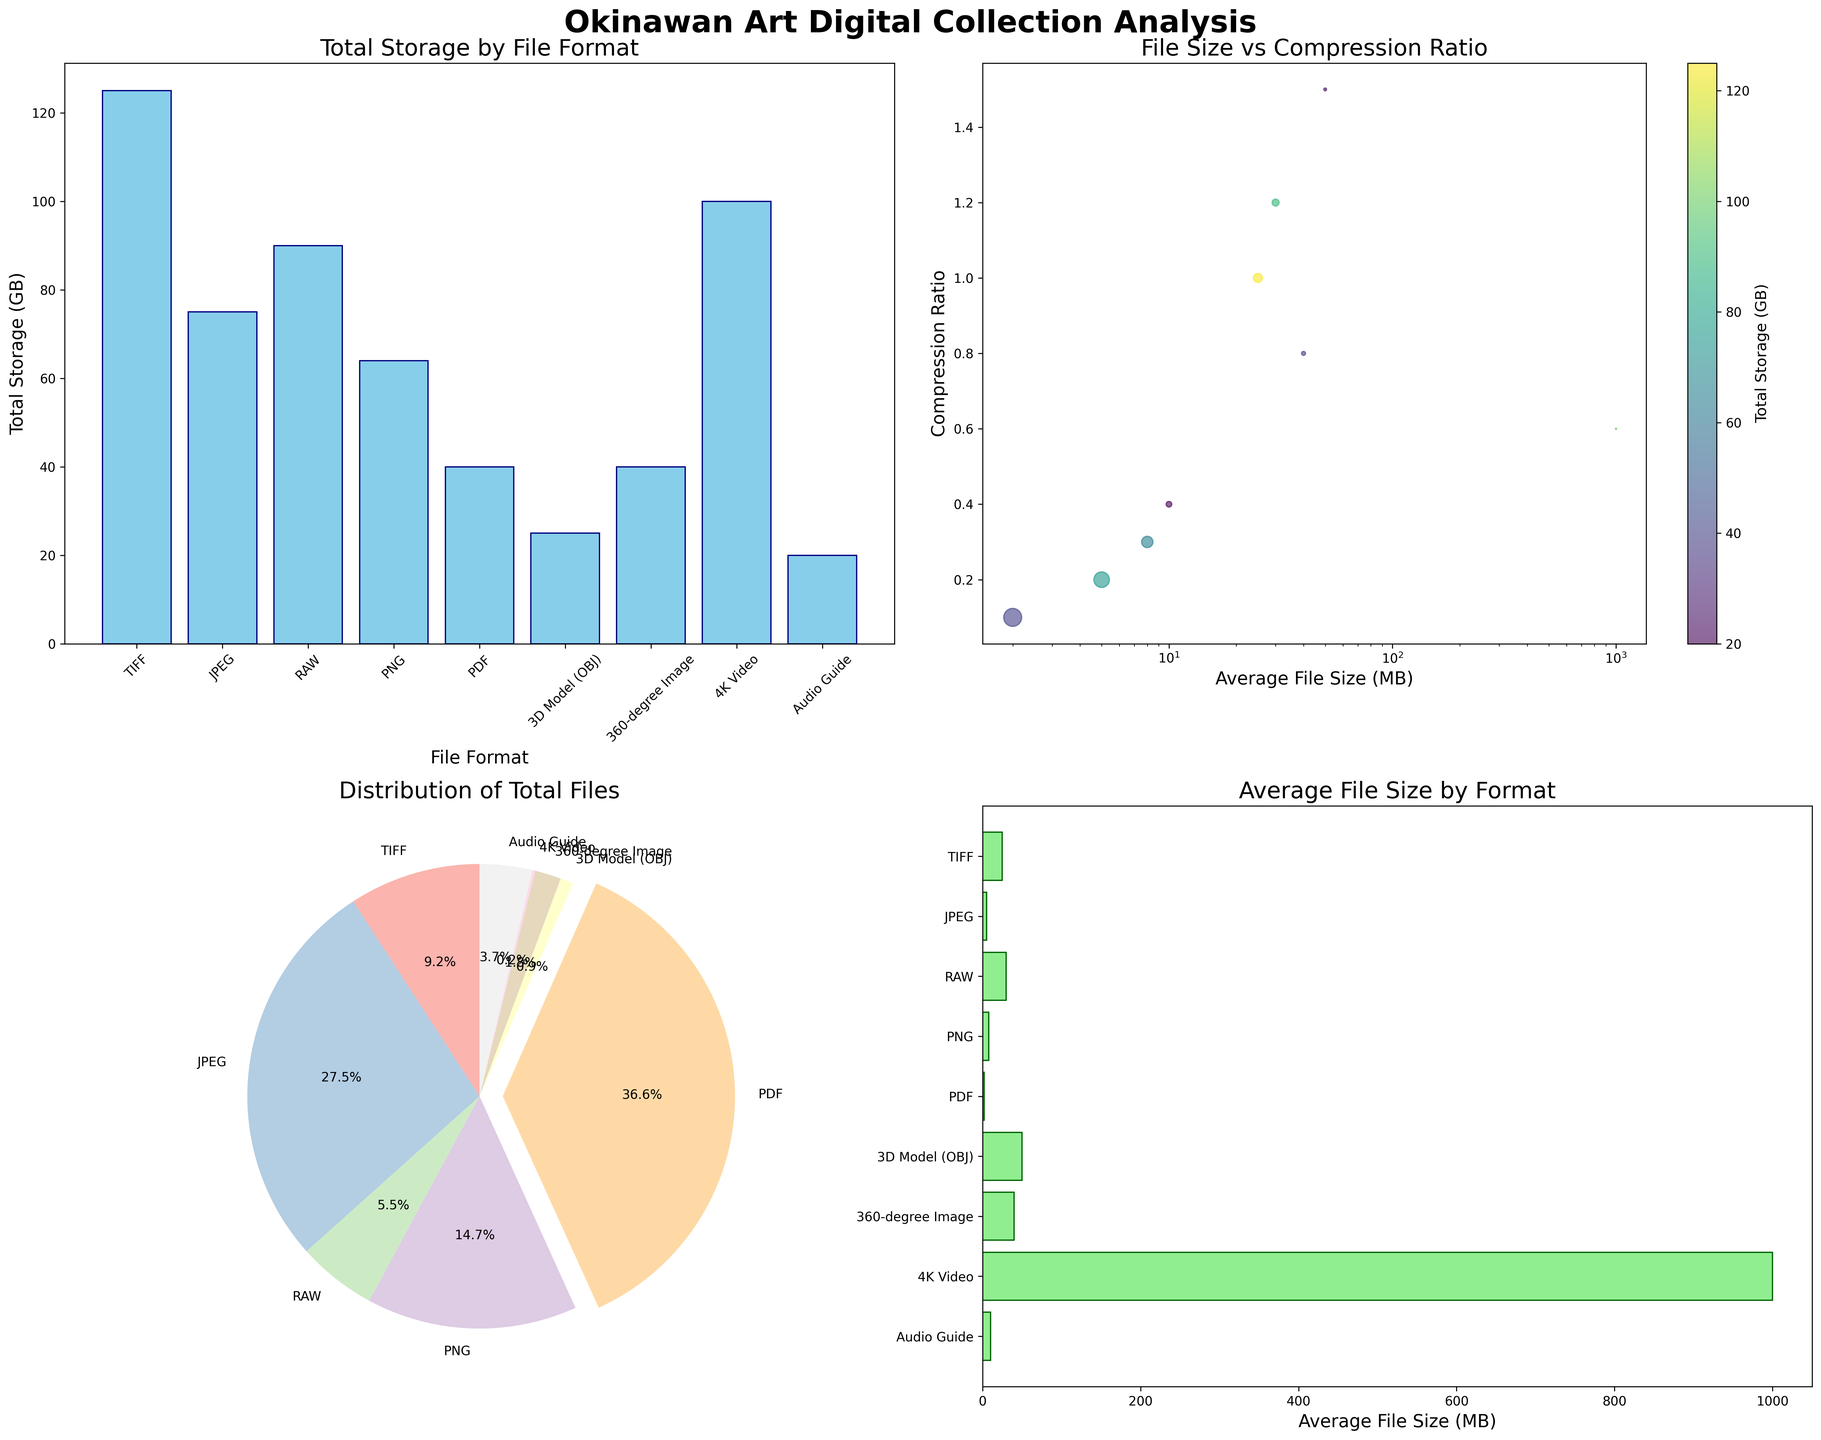How many total file formats are depicted in the bar plot for Total Storage by File Format? By counting the number of different bars representing file formats in the bar plot, we observe there are nine distinct file formats shown.
Answer: 9 What is the file format with the highest total storage in GB? By examining the heights of the bars in the Total Storage by File Format plot, TIFF has the highest bar implying it has the highest total storage of 125 GB.
Answer: TIFF Which file format has the largest average file size as shown in the horizontal bar chart? By looking at the horizontal bar chart to see which bar extends the furthest to the right, it is the 4K Video format with 1000 MB average file size.
Answer: 4K Video Among JPEG and PNG, which format has more total files? Referencing the pie chart, we see that JPEG occupies a larger portion of the pie compared to PNG, indicating JPEG has more total files.
Answer: JPEG What's the range of compression ratios visualized in the scatter plot? By looking at the y-axis values of the scatter plot for the minimum and maximum compression ratios, the minimum is around 0.1 and the maximum is around 1.5.
Answer: 0.1 to 1.5 Which file format contributes the smallest total storage and what is its value? Observing the smallest bar in the Total Storage by File Format plot, 3D Model (OBJ) has the smallest total storage which is 25 GB.
Answer: 3D Model (OBJ), 25 GB What's the average total storage in GB across all file formats depicted in the bar plot? Adding up all the storage values from the bar plot (125 + 75 + 90 + 64 + 40 + 25 + 40 + 100 + 20 = 579) and dividing by the number of formats (9), the average total storage is approximately 64.33 GB.
Answer: 64.33 GB How does the total number of audio guides compare to the total number of 4K videos? The total number of audio guides is much higher than that of 4K videos, as seen in the pie chart where audio guides take up a larger part compared to the very small section for 4K videos.
Answer: Audio guides have more Which file format has a compression ratio of about 0.2 and what is its average file size? In the scatter plot, the point near the compression ratio of 0.2 corresponds to the JPEG format, which has an average file size of 5 MB.
Answer: JPEG, 5 MB How does the average file size of RAW compare to TIFF according to the horizontal bar chart? The horizontal bar chart shows that the average file size of RAW (30 MB) is larger than that of TIFF (25 MB).
Answer: RAW is larger 